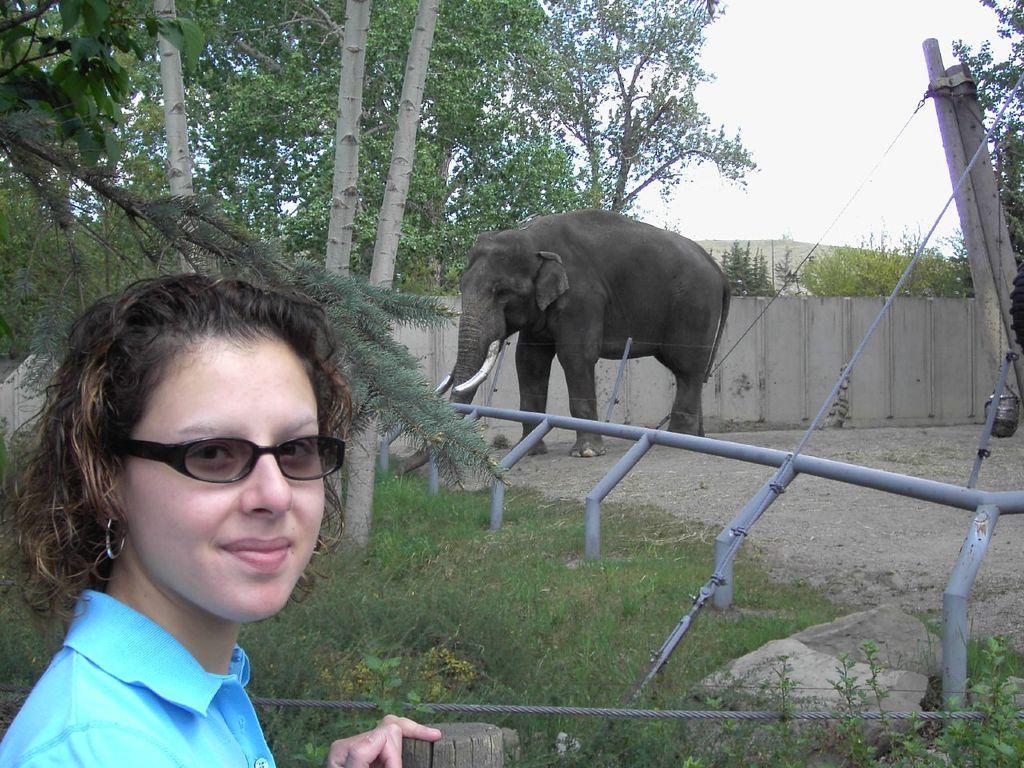Can you describe this image briefly? In this image there is a woman with a smile on her face, behind the woman there is grass, trees, an elephant. The elephant is inside a wooden fence. 